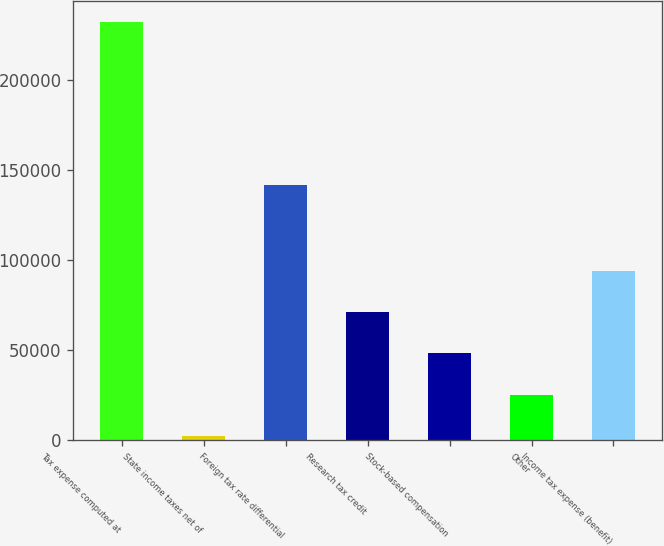Convert chart. <chart><loc_0><loc_0><loc_500><loc_500><bar_chart><fcel>Tax expense computed at<fcel>State income taxes net of<fcel>Foreign tax rate differential<fcel>Research tax credit<fcel>Stock-based compensation<fcel>Other<fcel>Income tax expense (benefit)<nl><fcel>232189<fcel>2302<fcel>142071<fcel>71268.1<fcel>48279.4<fcel>25290.7<fcel>94256.8<nl></chart> 